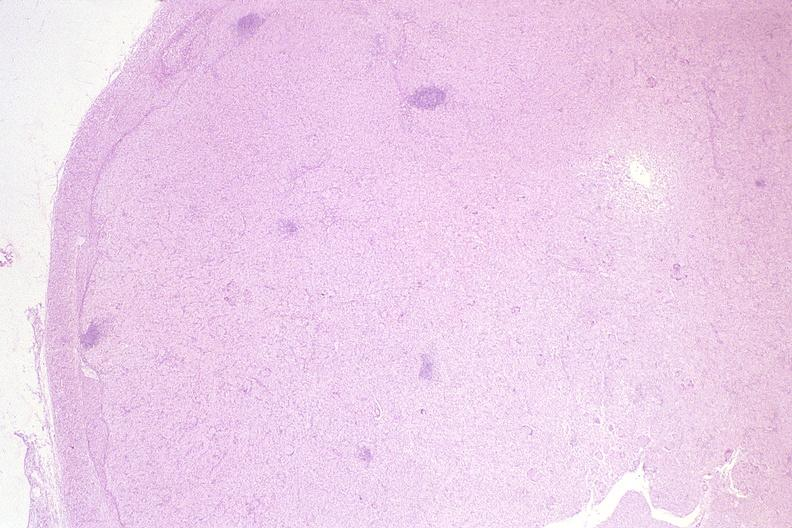does postpartum show lymph node, mycobacterium avium-intracellularae?
Answer the question using a single word or phrase. No 